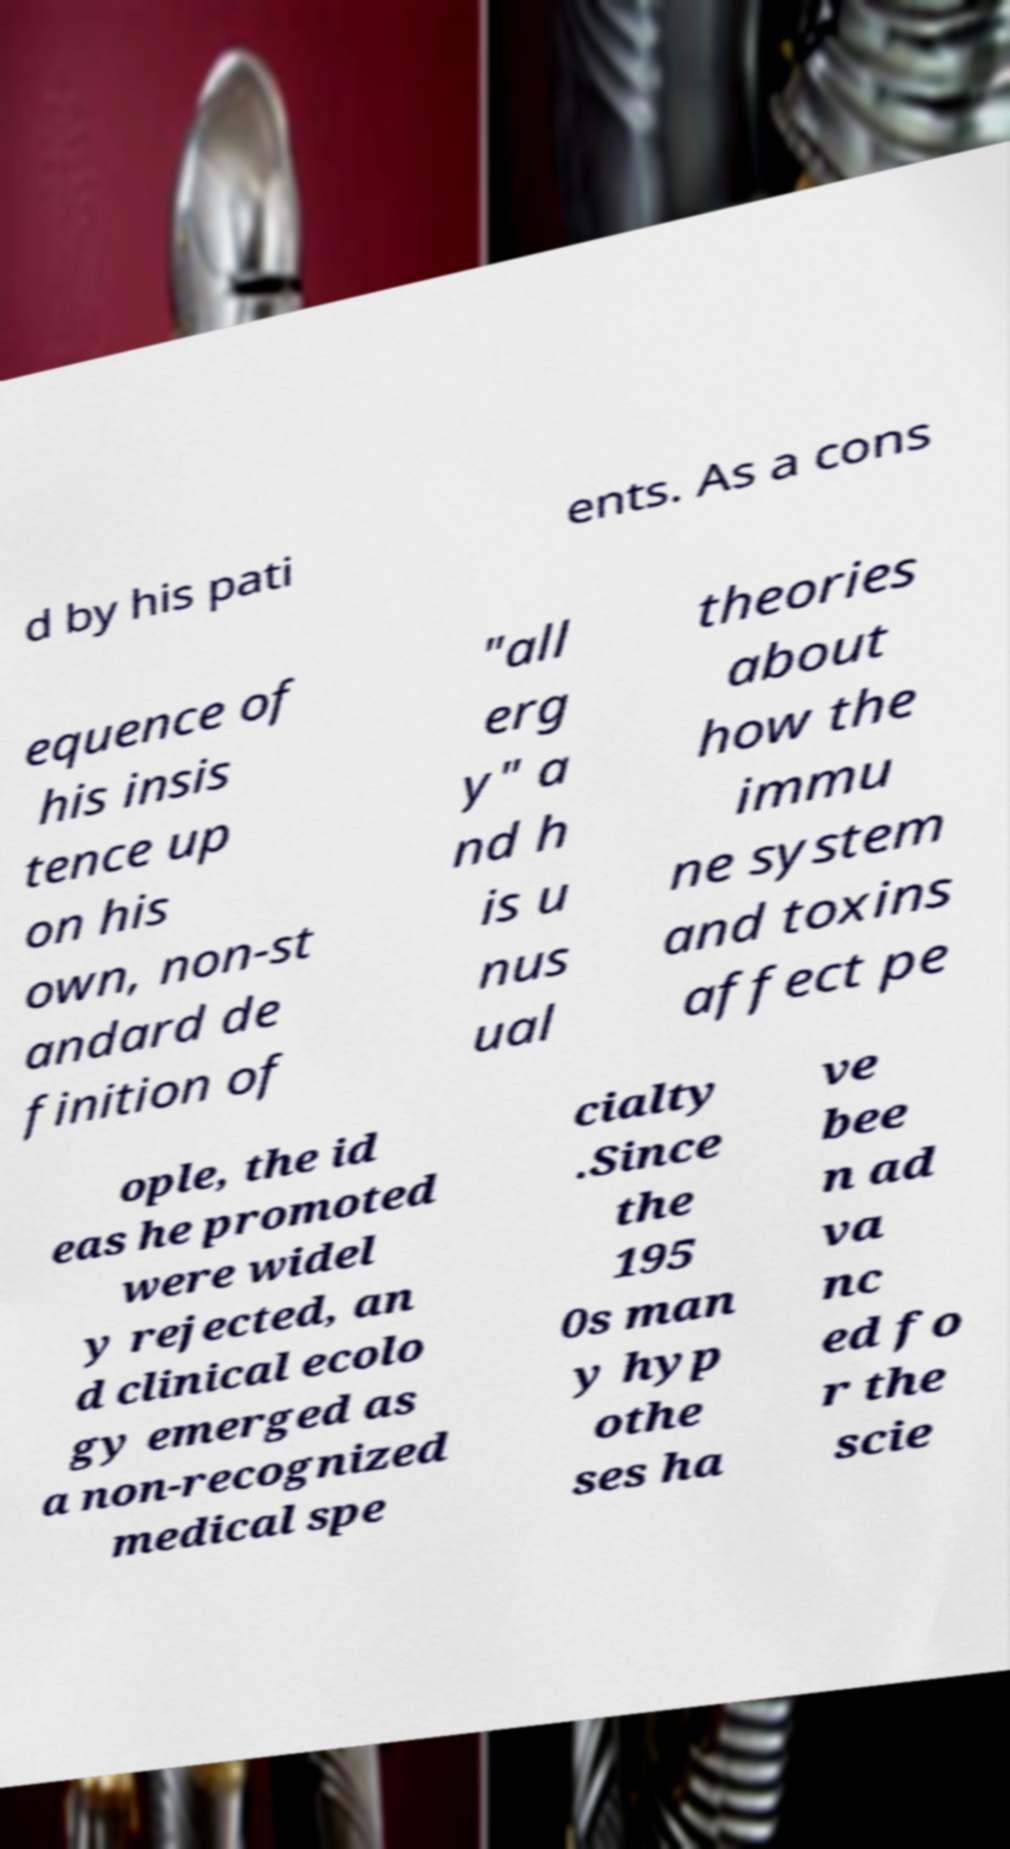I need the written content from this picture converted into text. Can you do that? d by his pati ents. As a cons equence of his insis tence up on his own, non-st andard de finition of "all erg y" a nd h is u nus ual theories about how the immu ne system and toxins affect pe ople, the id eas he promoted were widel y rejected, an d clinical ecolo gy emerged as a non-recognized medical spe cialty .Since the 195 0s man y hyp othe ses ha ve bee n ad va nc ed fo r the scie 